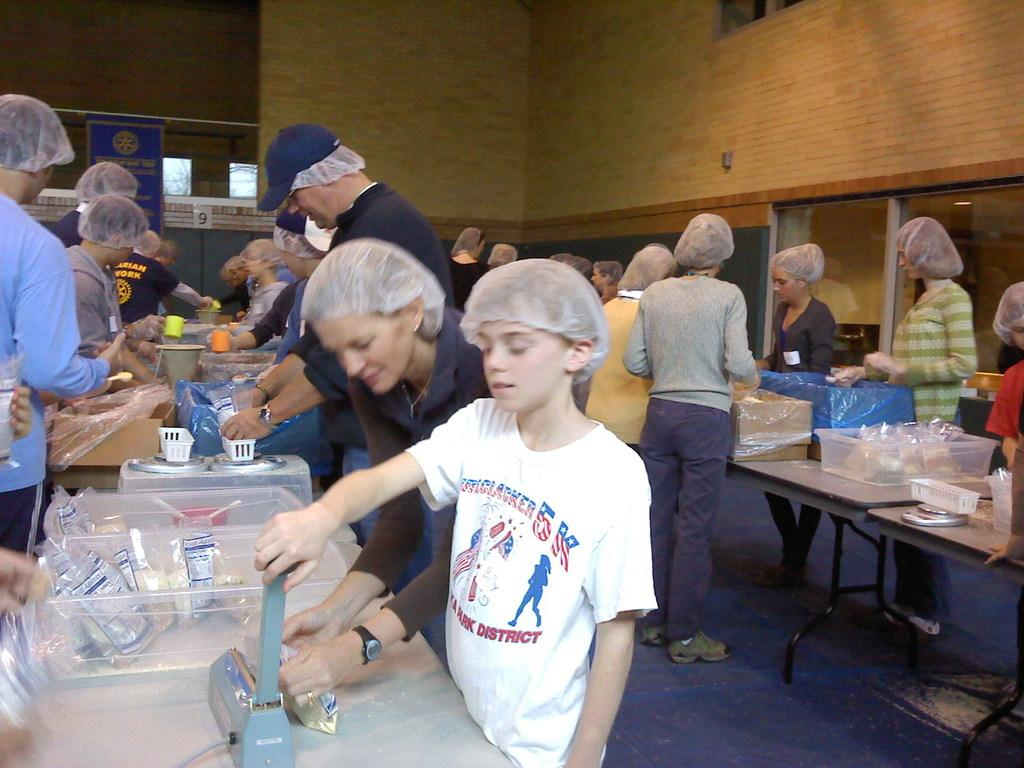How many persons are visible in the image? There are persons standing in the image. What surface are the persons standing on? The persons are standing on the floor. What furniture is present in the image? There is a table in the image. What object is on the table? There is a box on the table. Can you describe the attire of one of the persons? One person is wearing a cap. What can be seen in the background of the image? There is a wall in the background of the image. What month is it in the image? The month cannot be determined from the image, as there is no information about the time of year or season. What type of shirt is the person wearing in the image? There is no information about the person's shirt in the image, as the focus is on the cap as a detail about their attire. 